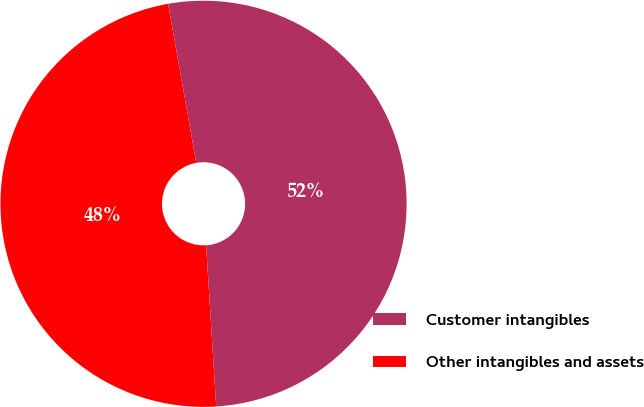Convert chart to OTSL. <chart><loc_0><loc_0><loc_500><loc_500><pie_chart><fcel>Customer intangibles<fcel>Other intangibles and assets<nl><fcel>51.8%<fcel>48.2%<nl></chart> 